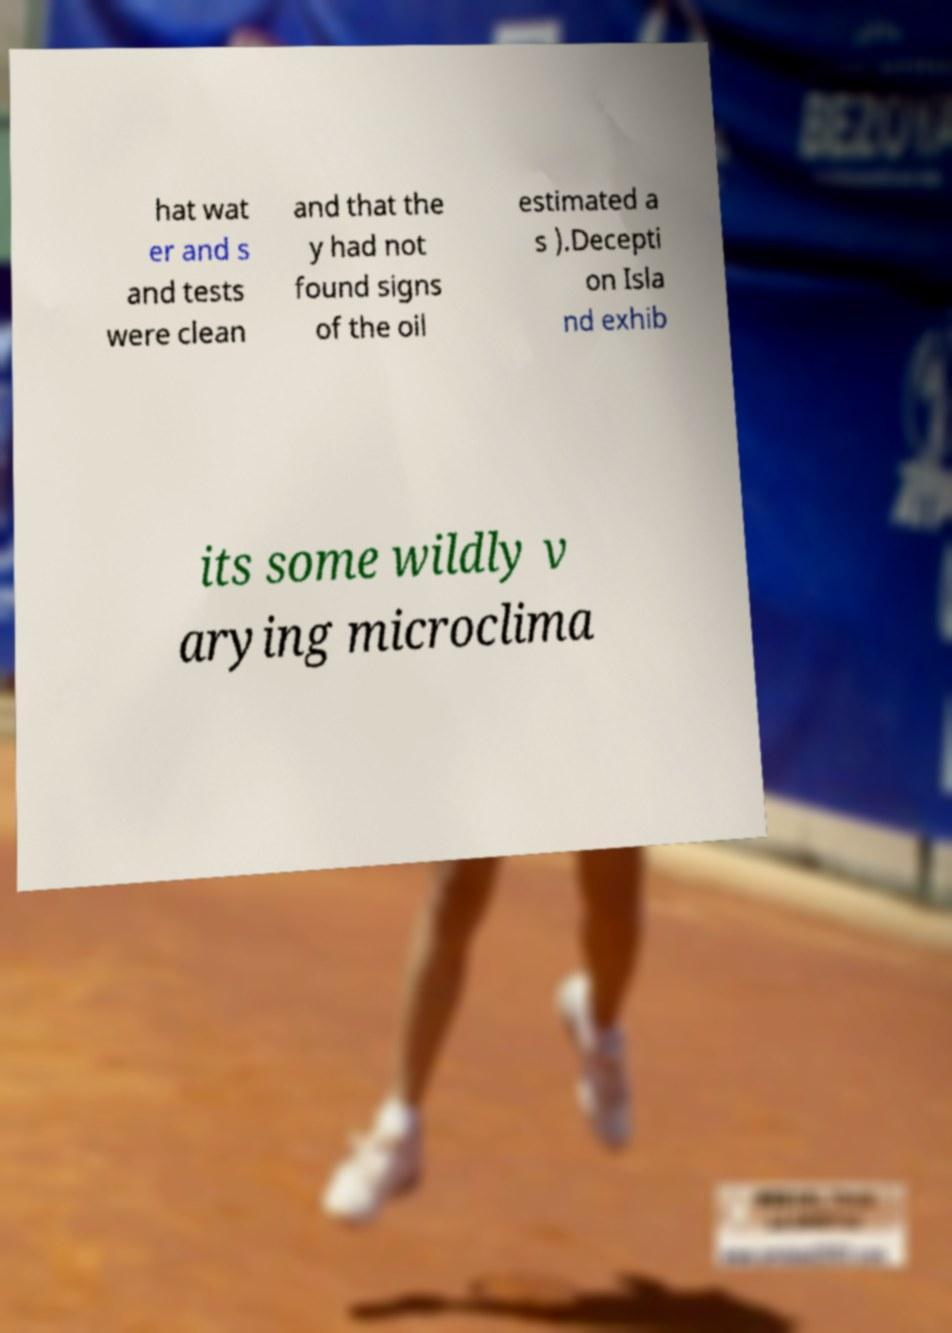Could you assist in decoding the text presented in this image and type it out clearly? hat wat er and s and tests were clean and that the y had not found signs of the oil estimated a s ).Decepti on Isla nd exhib its some wildly v arying microclima 